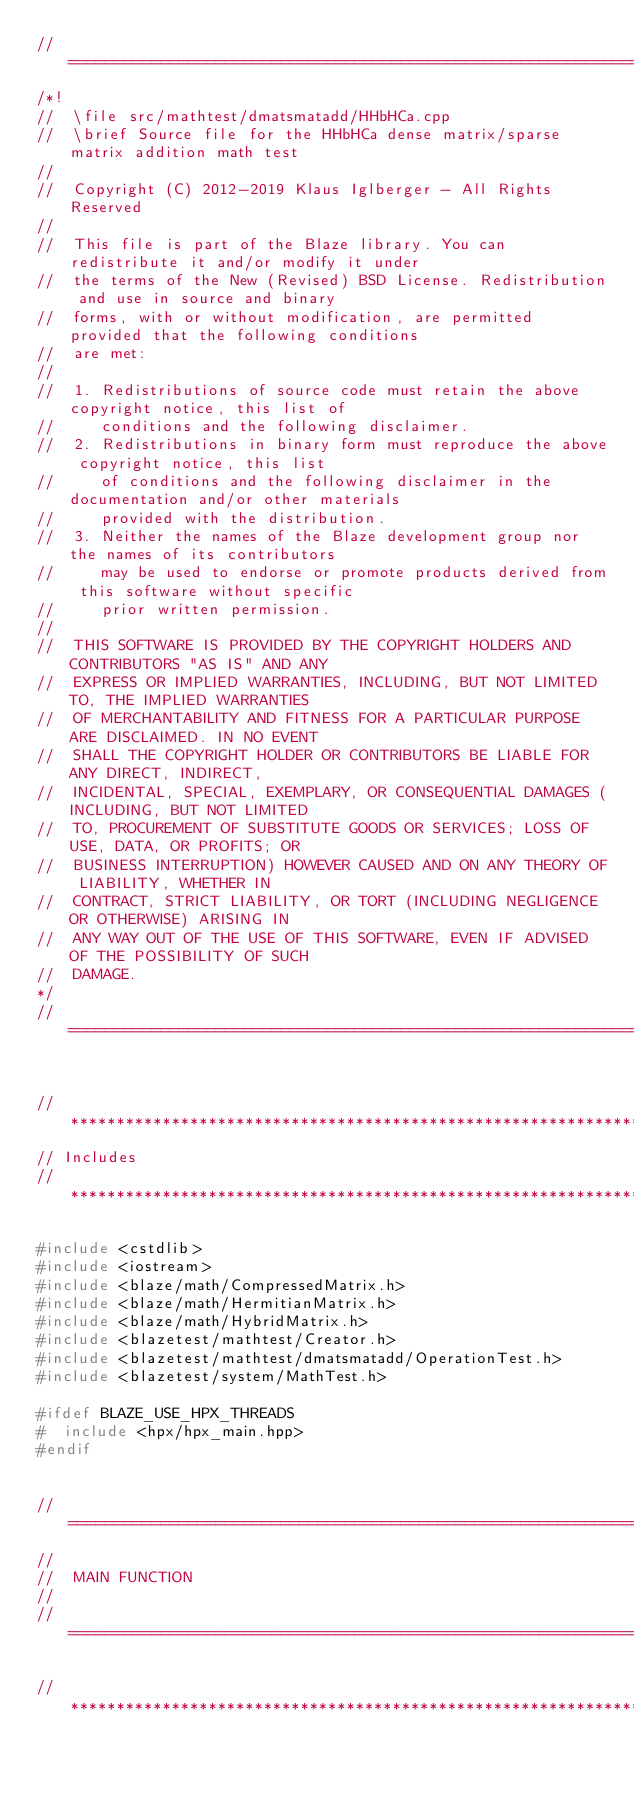Convert code to text. <code><loc_0><loc_0><loc_500><loc_500><_C++_>//=================================================================================================
/*!
//  \file src/mathtest/dmatsmatadd/HHbHCa.cpp
//  \brief Source file for the HHbHCa dense matrix/sparse matrix addition math test
//
//  Copyright (C) 2012-2019 Klaus Iglberger - All Rights Reserved
//
//  This file is part of the Blaze library. You can redistribute it and/or modify it under
//  the terms of the New (Revised) BSD License. Redistribution and use in source and binary
//  forms, with or without modification, are permitted provided that the following conditions
//  are met:
//
//  1. Redistributions of source code must retain the above copyright notice, this list of
//     conditions and the following disclaimer.
//  2. Redistributions in binary form must reproduce the above copyright notice, this list
//     of conditions and the following disclaimer in the documentation and/or other materials
//     provided with the distribution.
//  3. Neither the names of the Blaze development group nor the names of its contributors
//     may be used to endorse or promote products derived from this software without specific
//     prior written permission.
//
//  THIS SOFTWARE IS PROVIDED BY THE COPYRIGHT HOLDERS AND CONTRIBUTORS "AS IS" AND ANY
//  EXPRESS OR IMPLIED WARRANTIES, INCLUDING, BUT NOT LIMITED TO, THE IMPLIED WARRANTIES
//  OF MERCHANTABILITY AND FITNESS FOR A PARTICULAR PURPOSE ARE DISCLAIMED. IN NO EVENT
//  SHALL THE COPYRIGHT HOLDER OR CONTRIBUTORS BE LIABLE FOR ANY DIRECT, INDIRECT,
//  INCIDENTAL, SPECIAL, EXEMPLARY, OR CONSEQUENTIAL DAMAGES (INCLUDING, BUT NOT LIMITED
//  TO, PROCUREMENT OF SUBSTITUTE GOODS OR SERVICES; LOSS OF USE, DATA, OR PROFITS; OR
//  BUSINESS INTERRUPTION) HOWEVER CAUSED AND ON ANY THEORY OF LIABILITY, WHETHER IN
//  CONTRACT, STRICT LIABILITY, OR TORT (INCLUDING NEGLIGENCE OR OTHERWISE) ARISING IN
//  ANY WAY OUT OF THE USE OF THIS SOFTWARE, EVEN IF ADVISED OF THE POSSIBILITY OF SUCH
//  DAMAGE.
*/
//=================================================================================================


//*************************************************************************************************
// Includes
//*************************************************************************************************

#include <cstdlib>
#include <iostream>
#include <blaze/math/CompressedMatrix.h>
#include <blaze/math/HermitianMatrix.h>
#include <blaze/math/HybridMatrix.h>
#include <blazetest/mathtest/Creator.h>
#include <blazetest/mathtest/dmatsmatadd/OperationTest.h>
#include <blazetest/system/MathTest.h>

#ifdef BLAZE_USE_HPX_THREADS
#  include <hpx/hpx_main.hpp>
#endif


//=================================================================================================
//
//  MAIN FUNCTION
//
//=================================================================================================

//*************************************************************************************************</code> 